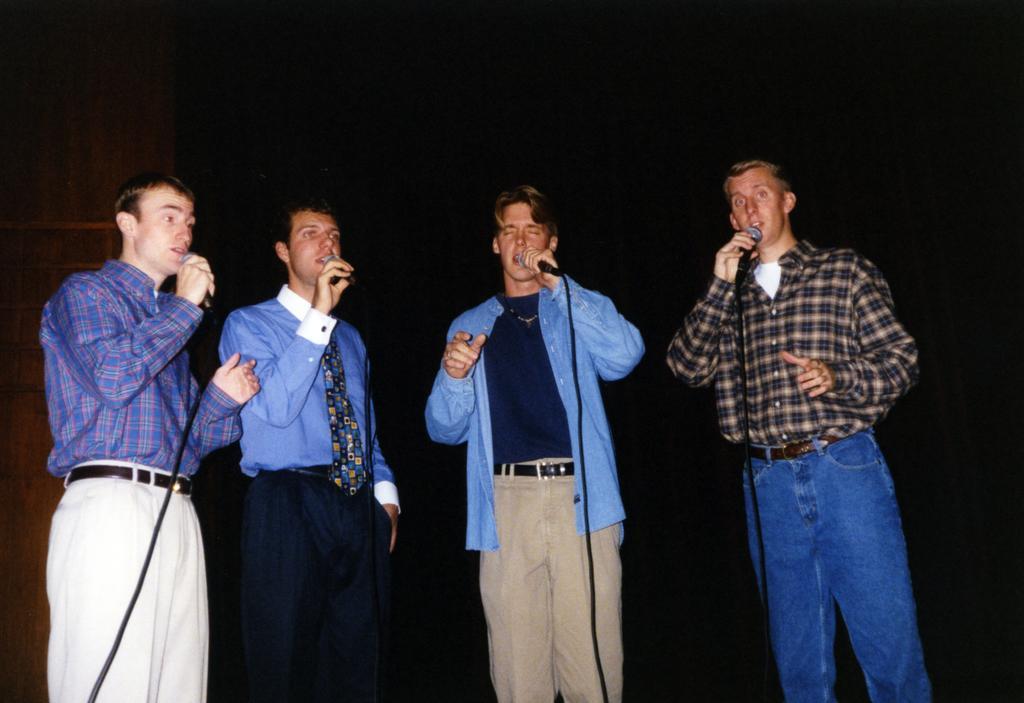Can you describe this image briefly? In this image we can see people holding mikes and we can also see the dark background. 